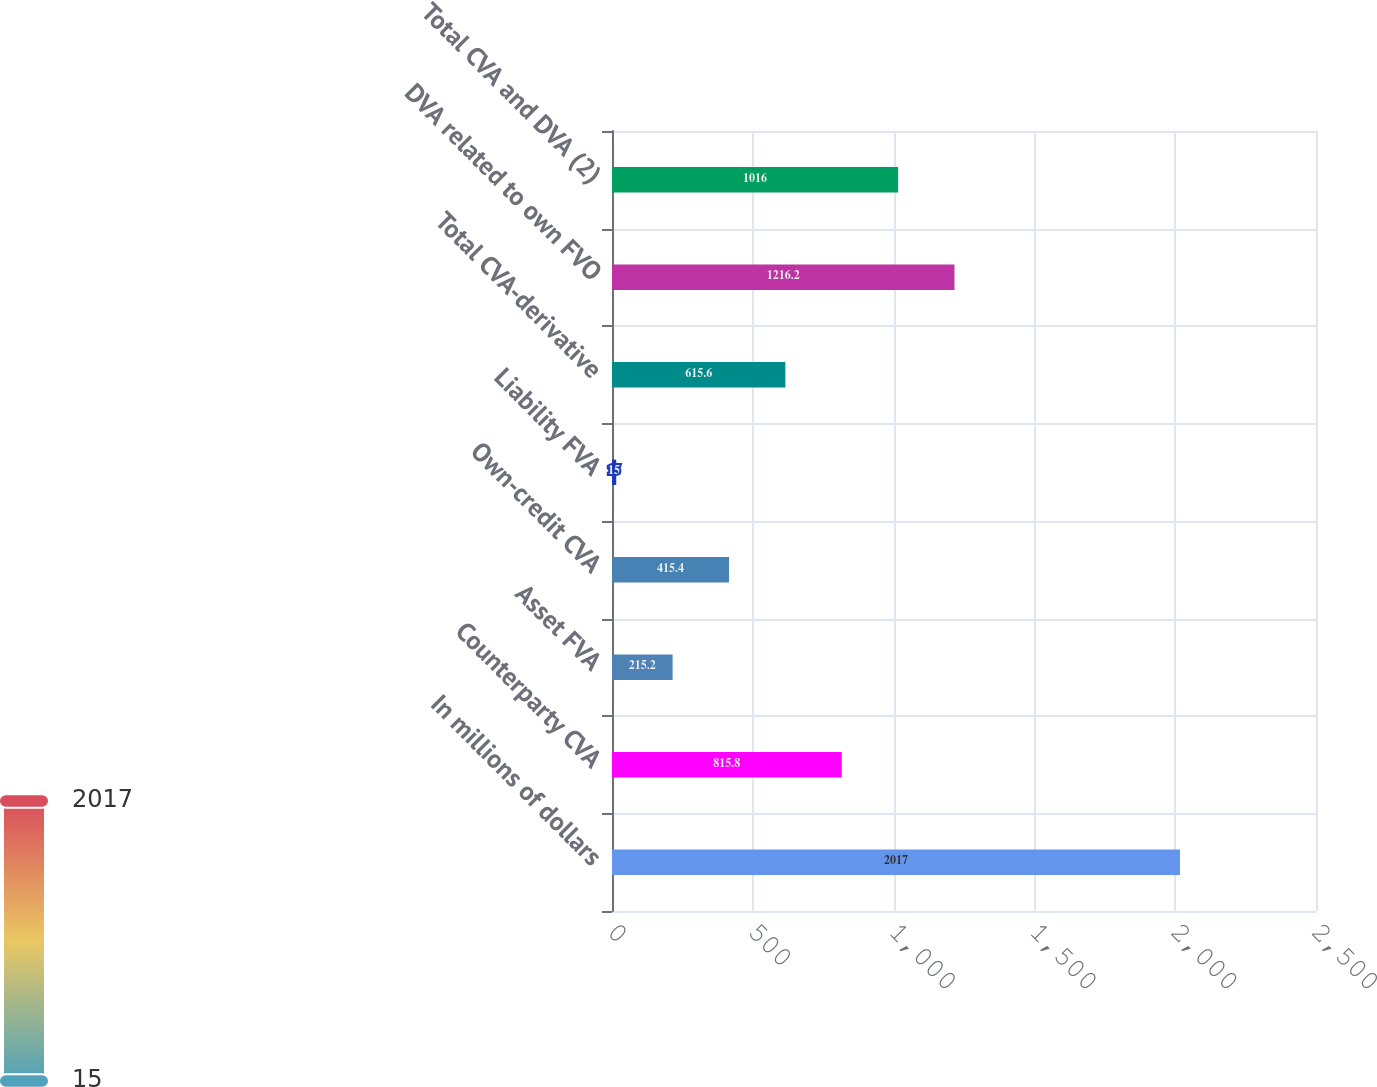Convert chart to OTSL. <chart><loc_0><loc_0><loc_500><loc_500><bar_chart><fcel>In millions of dollars<fcel>Counterparty CVA<fcel>Asset FVA<fcel>Own-credit CVA<fcel>Liability FVA<fcel>Total CVA-derivative<fcel>DVA related to own FVO<fcel>Total CVA and DVA (2)<nl><fcel>2017<fcel>815.8<fcel>215.2<fcel>415.4<fcel>15<fcel>615.6<fcel>1216.2<fcel>1016<nl></chart> 